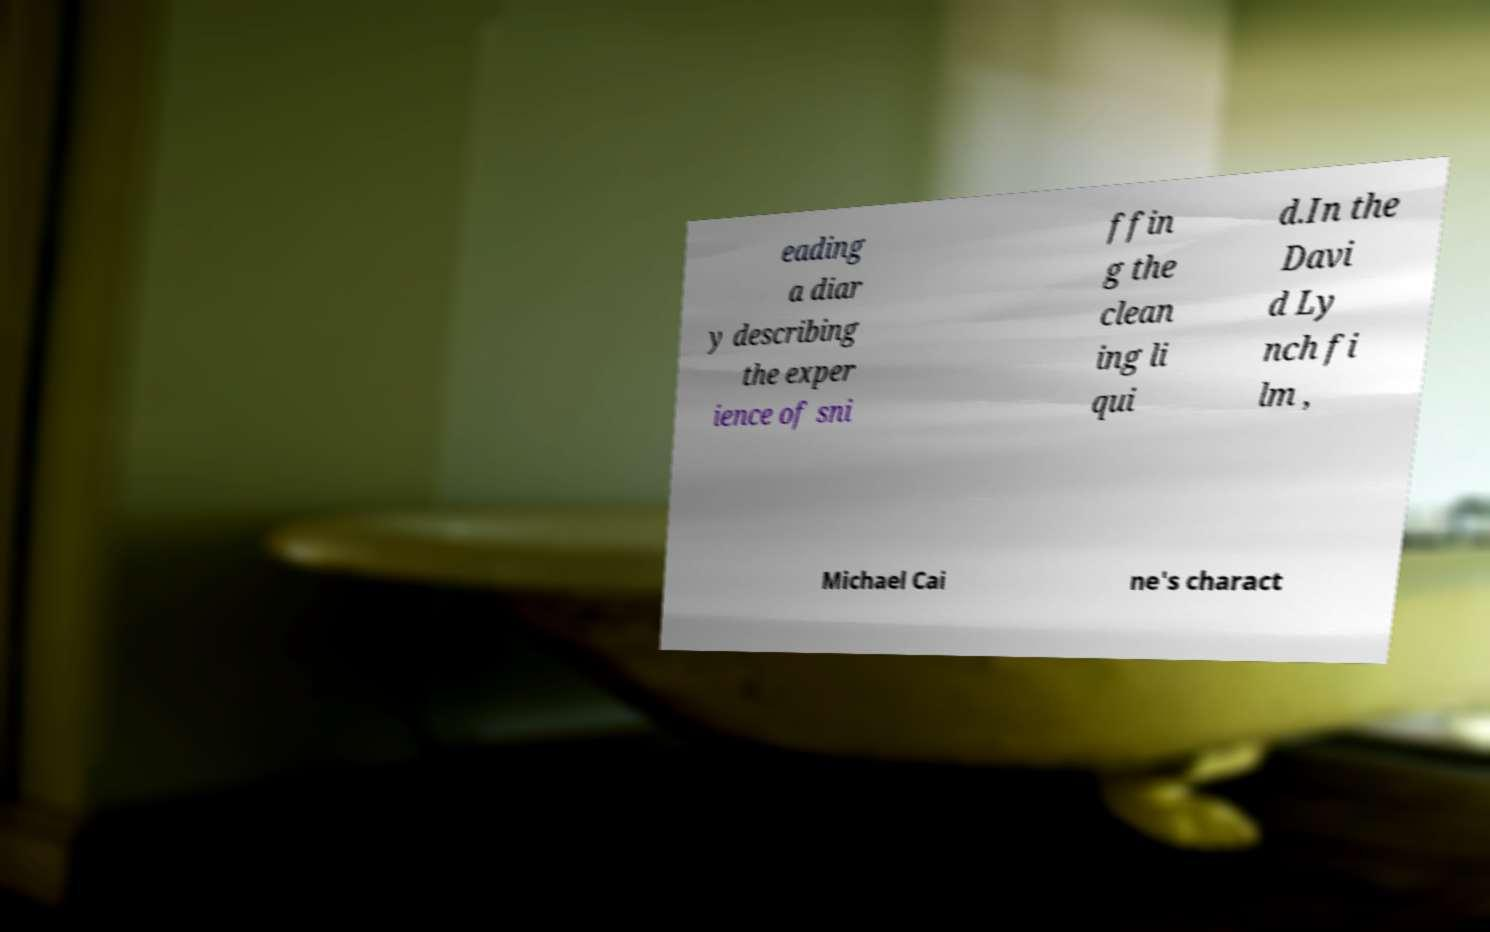Can you read and provide the text displayed in the image?This photo seems to have some interesting text. Can you extract and type it out for me? eading a diar y describing the exper ience of sni ffin g the clean ing li qui d.In the Davi d Ly nch fi lm , Michael Cai ne's charact 